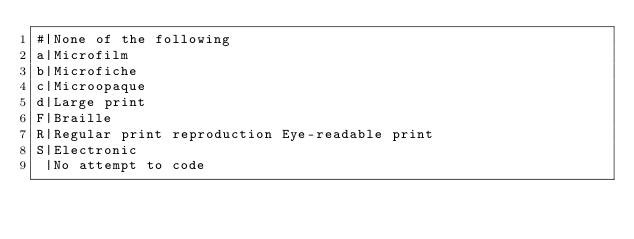<code> <loc_0><loc_0><loc_500><loc_500><_SQL_>#|None of the following 
a|Microfilm 
b|Microfiche 
c|Microopaque 
d|Large print 
F|Braille 
R|Regular print reproduction Eye-readable print
S|Electronic 
 |No attempt to code
</code> 